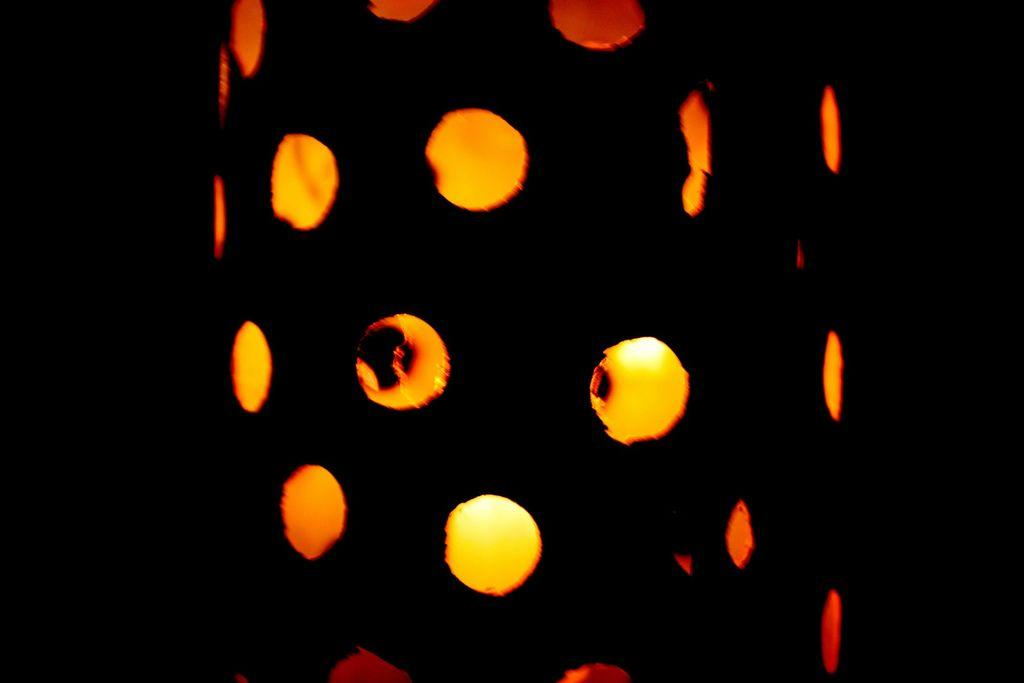What is the main object in the center of the image? There is a cylindrical object in the center of the image. What are the characteristics of the cylindrical object? The cylindrical object has holes, and light is visible through the holes. What is the color of the background in the image? The background of the image is black. How does the cylindrical object celebrate the holiday in the image? The cylindrical object does not celebrate any holiday in the image, as it is an inanimate object. What type of hydrant is present in the image? There is no hydrant present in the image; it features a cylindrical object with holes and a black background. 